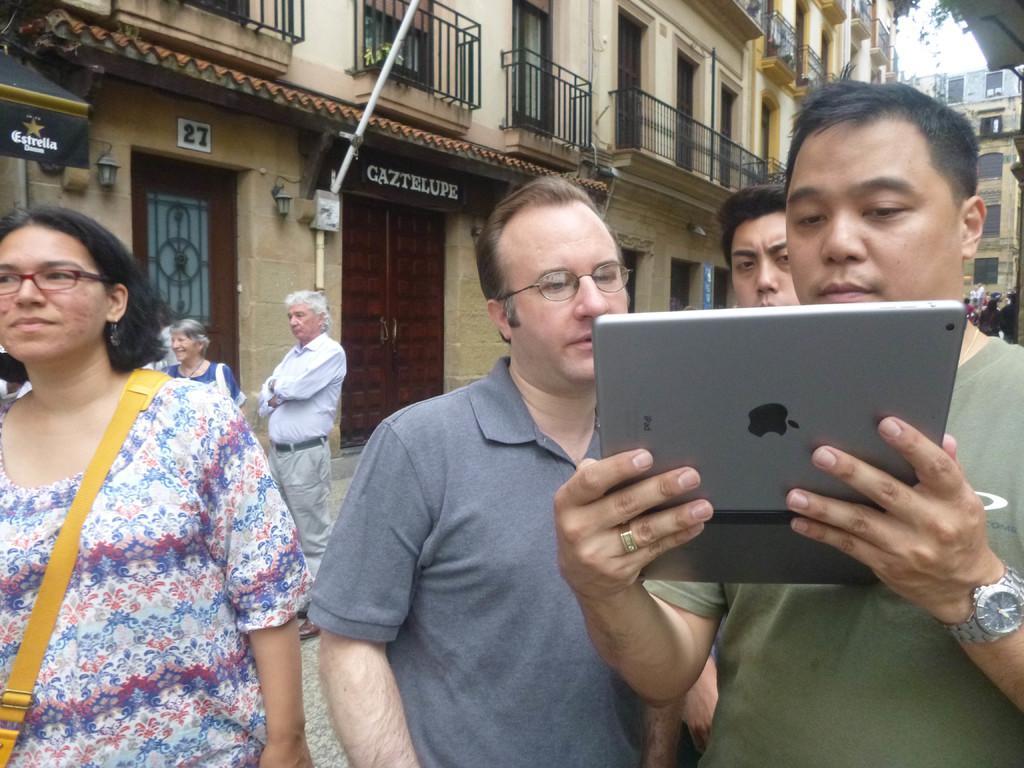Can you describe this image briefly? Here we can see few persons and he is holding an apple device with his hands. In the background we can see buildings, doors, boards, and sky. 